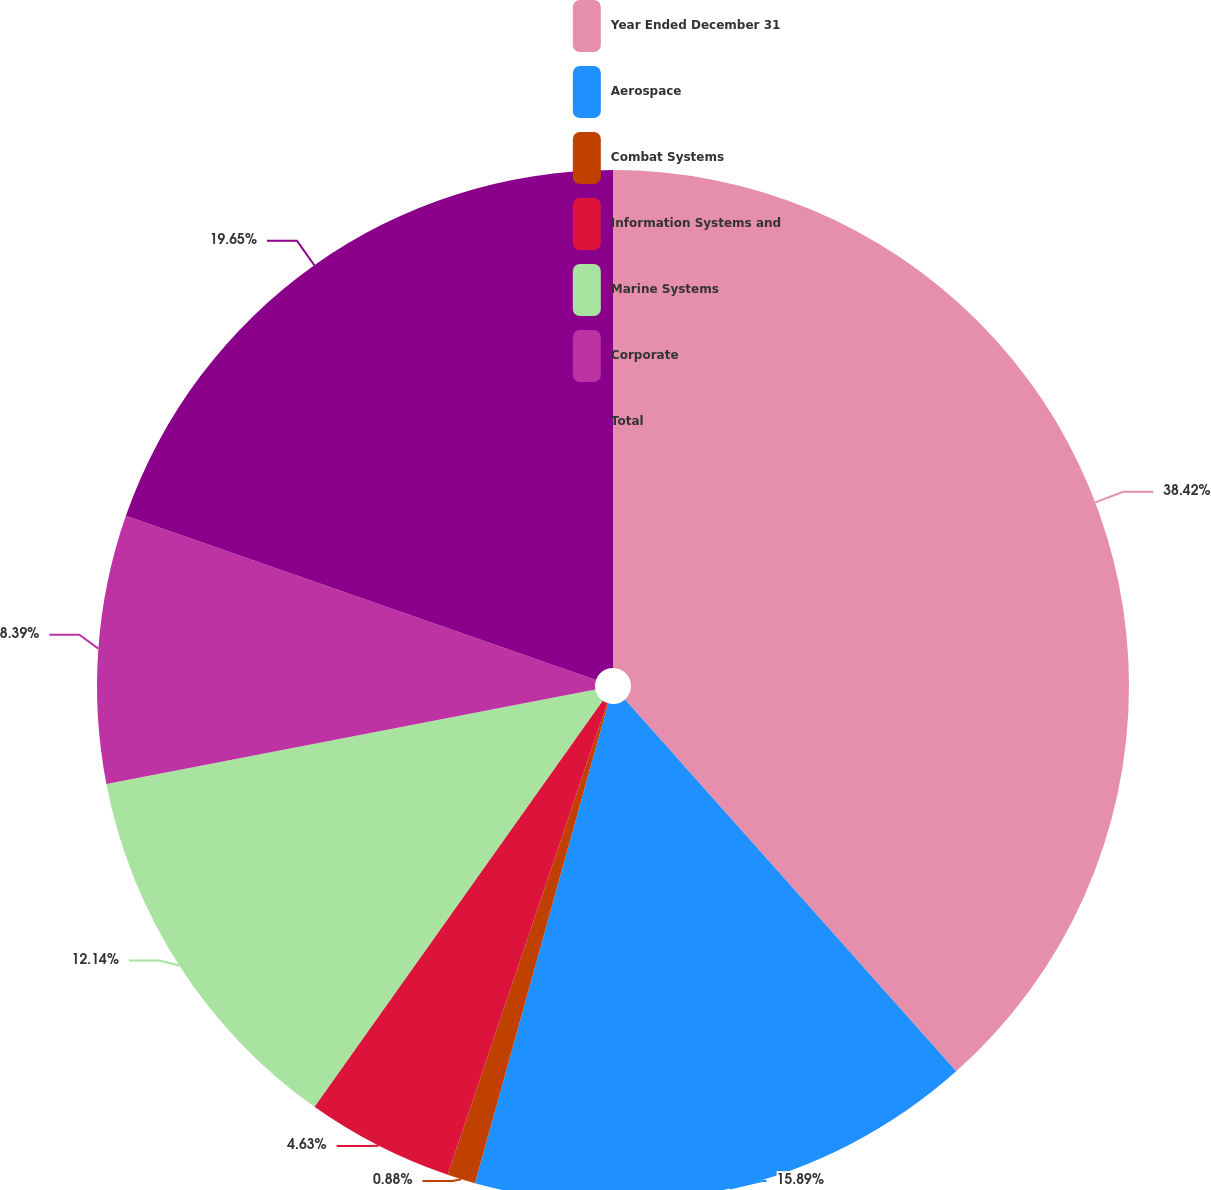Convert chart. <chart><loc_0><loc_0><loc_500><loc_500><pie_chart><fcel>Year Ended December 31<fcel>Aerospace<fcel>Combat Systems<fcel>Information Systems and<fcel>Marine Systems<fcel>Corporate<fcel>Total<nl><fcel>38.42%<fcel>15.89%<fcel>0.88%<fcel>4.63%<fcel>12.14%<fcel>8.39%<fcel>19.65%<nl></chart> 